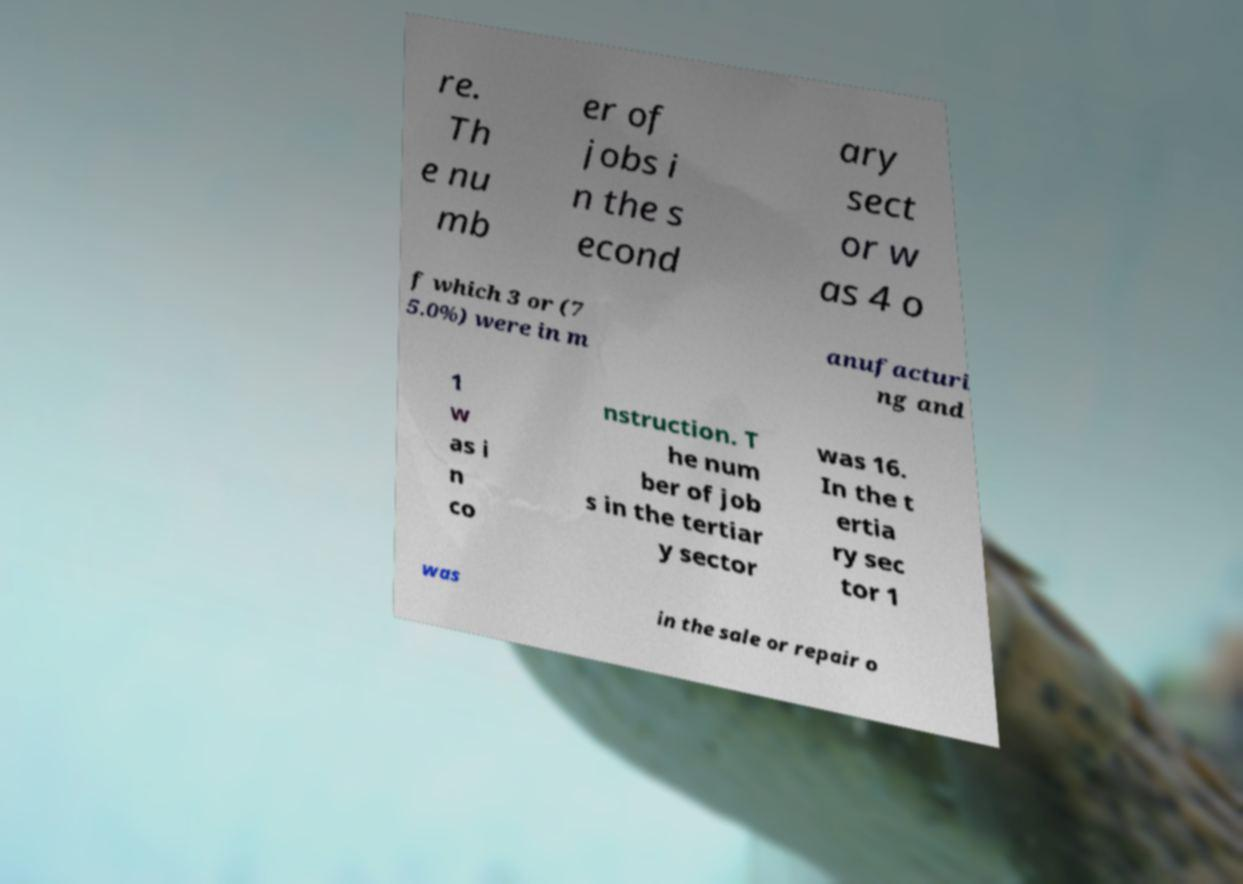Can you read and provide the text displayed in the image?This photo seems to have some interesting text. Can you extract and type it out for me? re. Th e nu mb er of jobs i n the s econd ary sect or w as 4 o f which 3 or (7 5.0%) were in m anufacturi ng and 1 w as i n co nstruction. T he num ber of job s in the tertiar y sector was 16. In the t ertia ry sec tor 1 was in the sale or repair o 